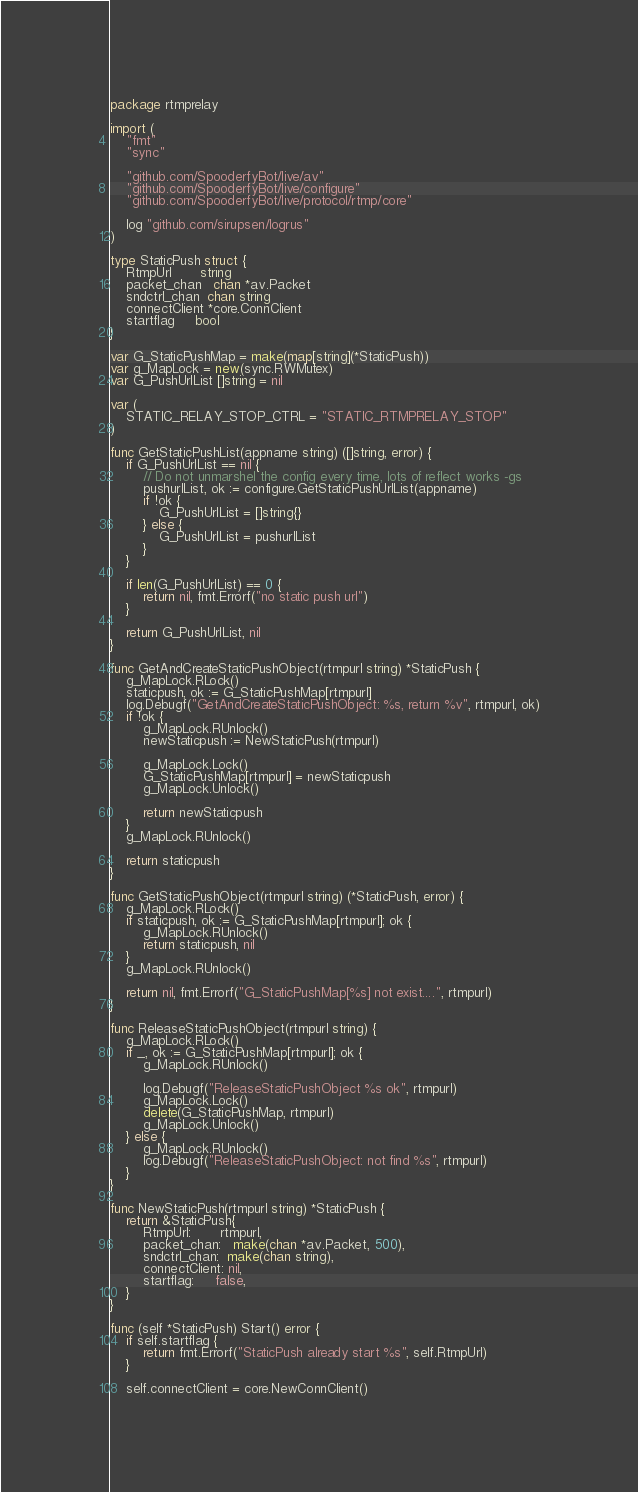<code> <loc_0><loc_0><loc_500><loc_500><_Go_>package rtmprelay

import (
	"fmt"
	"sync"

	"github.com/SpooderfyBot/live/av"
	"github.com/SpooderfyBot/live/configure"
	"github.com/SpooderfyBot/live/protocol/rtmp/core"

	log "github.com/sirupsen/logrus"
)

type StaticPush struct {
	RtmpUrl       string
	packet_chan   chan *av.Packet
	sndctrl_chan  chan string
	connectClient *core.ConnClient
	startflag     bool
}

var G_StaticPushMap = make(map[string](*StaticPush))
var g_MapLock = new(sync.RWMutex)
var G_PushUrlList []string = nil

var (
	STATIC_RELAY_STOP_CTRL = "STATIC_RTMPRELAY_STOP"
)

func GetStaticPushList(appname string) ([]string, error) {
	if G_PushUrlList == nil {
		// Do not unmarshel the config every time, lots of reflect works -gs
		pushurlList, ok := configure.GetStaticPushUrlList(appname)
		if !ok {
			G_PushUrlList = []string{}
		} else {
			G_PushUrlList = pushurlList
		}
	}

	if len(G_PushUrlList) == 0 {
		return nil, fmt.Errorf("no static push url")
	}

	return G_PushUrlList, nil
}

func GetAndCreateStaticPushObject(rtmpurl string) *StaticPush {
	g_MapLock.RLock()
	staticpush, ok := G_StaticPushMap[rtmpurl]
	log.Debugf("GetAndCreateStaticPushObject: %s, return %v", rtmpurl, ok)
	if !ok {
		g_MapLock.RUnlock()
		newStaticpush := NewStaticPush(rtmpurl)

		g_MapLock.Lock()
		G_StaticPushMap[rtmpurl] = newStaticpush
		g_MapLock.Unlock()

		return newStaticpush
	}
	g_MapLock.RUnlock()

	return staticpush
}

func GetStaticPushObject(rtmpurl string) (*StaticPush, error) {
	g_MapLock.RLock()
	if staticpush, ok := G_StaticPushMap[rtmpurl]; ok {
		g_MapLock.RUnlock()
		return staticpush, nil
	}
	g_MapLock.RUnlock()

	return nil, fmt.Errorf("G_StaticPushMap[%s] not exist....", rtmpurl)
}

func ReleaseStaticPushObject(rtmpurl string) {
	g_MapLock.RLock()
	if _, ok := G_StaticPushMap[rtmpurl]; ok {
		g_MapLock.RUnlock()

		log.Debugf("ReleaseStaticPushObject %s ok", rtmpurl)
		g_MapLock.Lock()
		delete(G_StaticPushMap, rtmpurl)
		g_MapLock.Unlock()
	} else {
		g_MapLock.RUnlock()
		log.Debugf("ReleaseStaticPushObject: not find %s", rtmpurl)
	}
}

func NewStaticPush(rtmpurl string) *StaticPush {
	return &StaticPush{
		RtmpUrl:       rtmpurl,
		packet_chan:   make(chan *av.Packet, 500),
		sndctrl_chan:  make(chan string),
		connectClient: nil,
		startflag:     false,
	}
}

func (self *StaticPush) Start() error {
	if self.startflag {
		return fmt.Errorf("StaticPush already start %s", self.RtmpUrl)
	}

	self.connectClient = core.NewConnClient()
</code> 